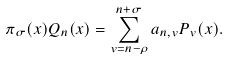Convert formula to latex. <formula><loc_0><loc_0><loc_500><loc_500>\pi _ { \sigma } ( x ) Q _ { n } ( x ) & = \sum _ { v = n - \rho } ^ { n + \sigma } a _ { n , v } P _ { v } ( x ) .</formula> 